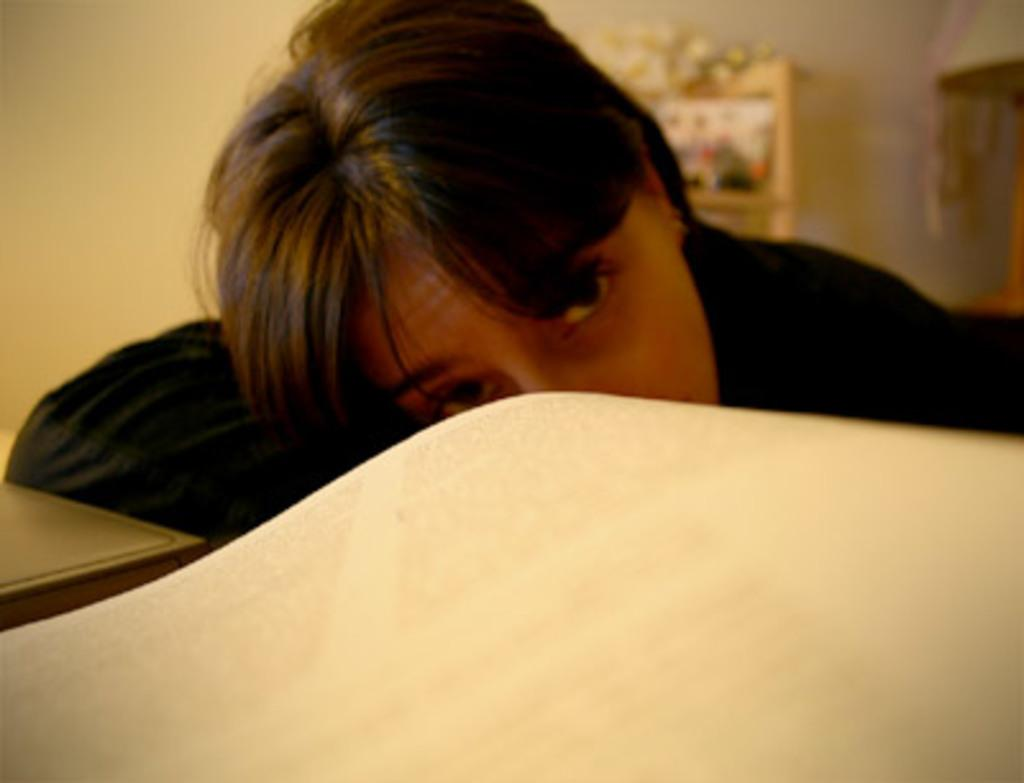Who is the main subject in the image? There is a girl in the image. What is the girl doing in the image? The girl is sleeping. Where are the girl's hands placed in the image? The girl has her hands on the table. What can be seen on the right side of the image? There is a mat on the right side of the image. What is visible in the background of the image? There is a wall in the background of the image. What type of apple is the girl eating in the image? There is no apple present in the image; the girl is sleeping with her hands on the table. Who is the servant attending to the girl in the image? There is no servant present in the image; the girl is sleeping alone. 